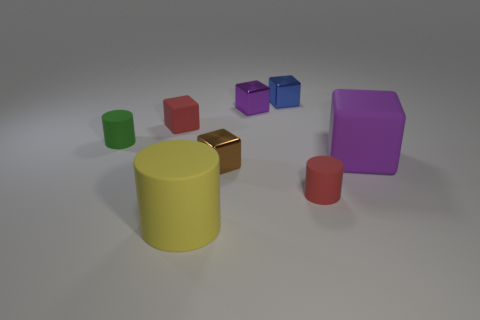Subtract all green cylinders. How many purple blocks are left? 2 Subtract all small cylinders. How many cylinders are left? 1 Subtract 2 cubes. How many cubes are left? 3 Subtract all brown cubes. How many cubes are left? 4 Add 2 big purple rubber things. How many objects exist? 10 Subtract all gray blocks. Subtract all gray balls. How many blocks are left? 5 Subtract all cubes. How many objects are left? 3 Subtract 0 blue cylinders. How many objects are left? 8 Subtract all small green rubber cylinders. Subtract all tiny things. How many objects are left? 1 Add 2 large things. How many large things are left? 4 